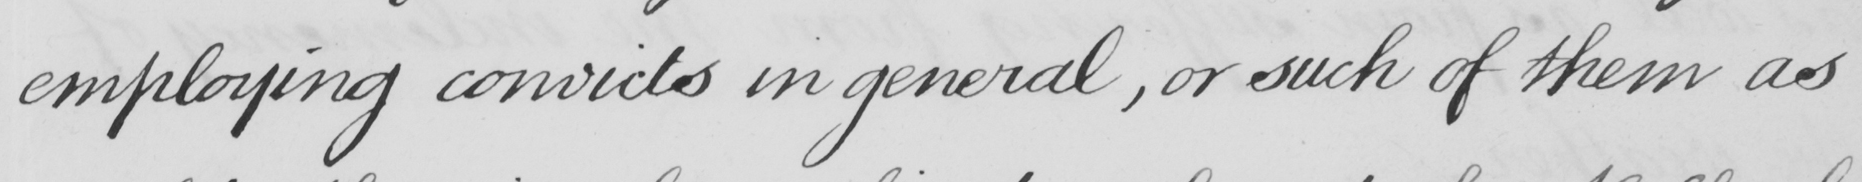Can you read and transcribe this handwriting? employing convicts in general , or such of them as 